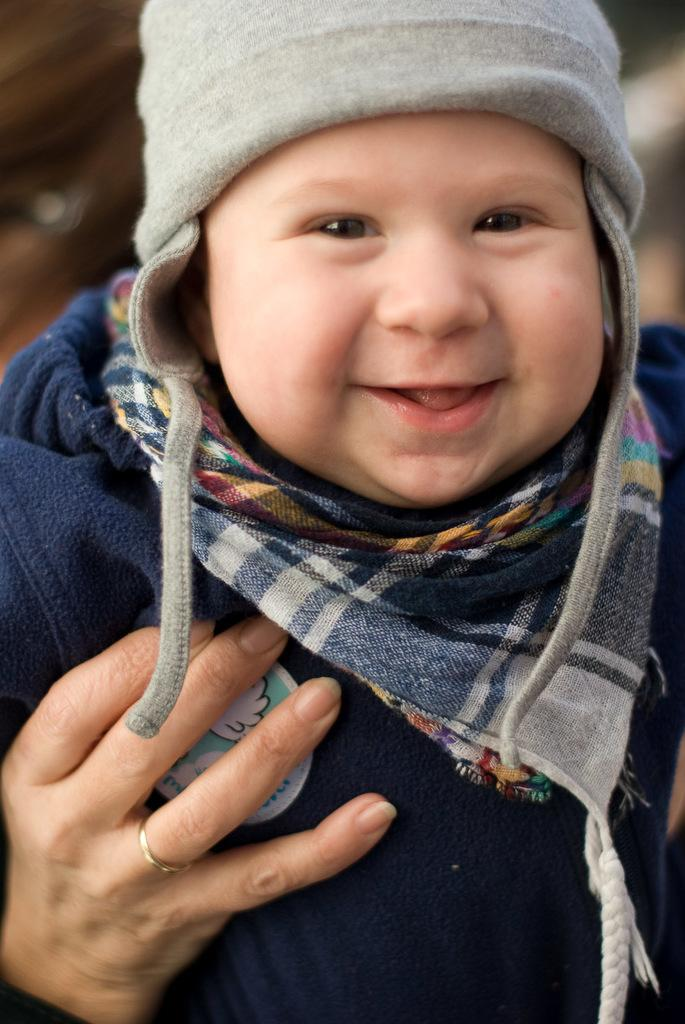What is the main subject of the image? There is a baby in the image. Can you describe any other elements in the image? There is a blurred hand in the background of the image. What are the baby's hobbies in the image? There is no information about the baby's hobbies in the image. What is the reason for the blurred hand in the image? There is no information about the reason for the blurred hand in the image. 